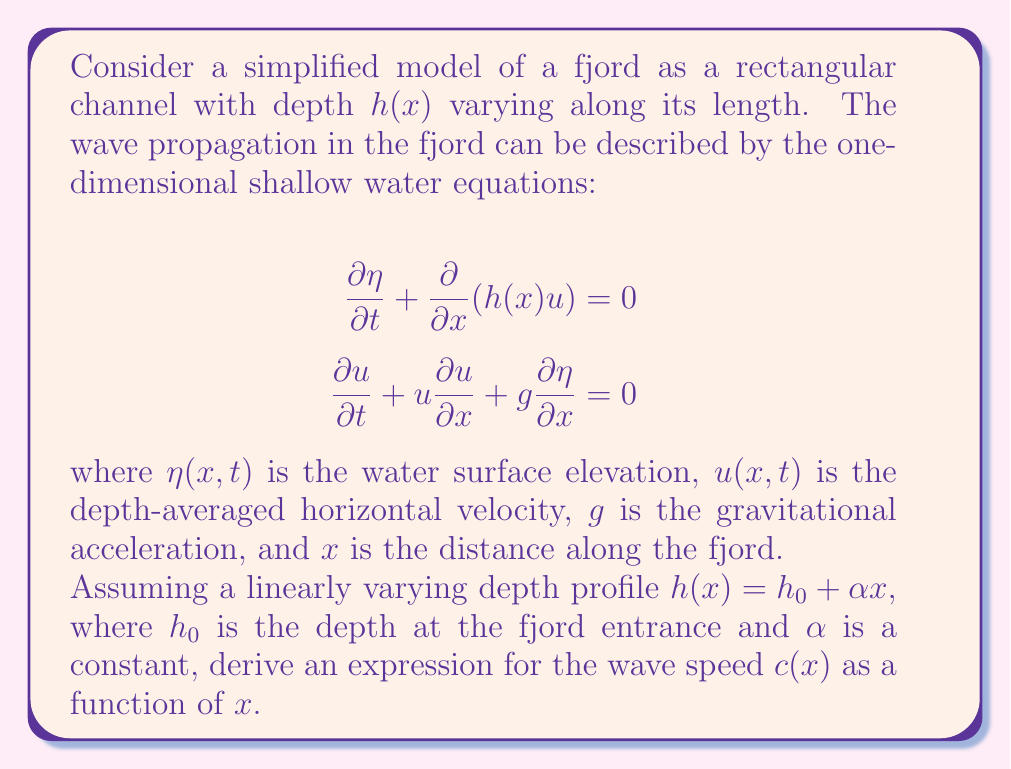Provide a solution to this math problem. To solve this problem, we'll follow these steps:

1) First, we need to linearize the shallow water equations for small perturbations. We assume that $\eta$ and $u$ are small, and neglect the nonlinear term $u\frac{\partial u}{\partial x}$.

2) The linearized equations become:

   $$\frac{\partial \eta}{\partial t} + \frac{\partial}{\partial x}(h(x)u) = 0$$
   $$\frac{\partial u}{\partial t} + g\frac{\partial \eta}{\partial x} = 0$$

3) We can combine these equations to get a single equation for $\eta$. Differentiate the first equation with respect to $t$ and the second with respect to $x$:

   $$\frac{\partial^2 \eta}{\partial t^2} + \frac{\partial^2}{\partial x\partial t}(h(x)u) = 0$$
   $$\frac{\partial^2 u}{\partial x\partial t} + g\frac{\partial^2 \eta}{\partial x^2} = 0$$

4) Substitute the second equation into the first:

   $$\frac{\partial^2 \eta}{\partial t^2} - \frac{\partial}{\partial x}(gh(x)\frac{\partial \eta}{\partial x}) = 0$$

5) This is a wave equation with variable coefficients. The wave speed $c(x)$ is given by:

   $$c(x) = \sqrt{gh(x)}$$

6) Substituting the given depth profile $h(x) = h_0 + \alpha x$:

   $$c(x) = \sqrt{g(h_0 + \alpha x)}$$

7) This expression gives the wave speed as a function of distance along the fjord.
Answer: The wave speed $c(x)$ as a function of distance $x$ along the fjord is:

$$c(x) = \sqrt{g(h_0 + \alpha x)}$$

where $g$ is the gravitational acceleration, $h_0$ is the depth at the fjord entrance, and $\alpha$ is the constant in the linear depth profile. 